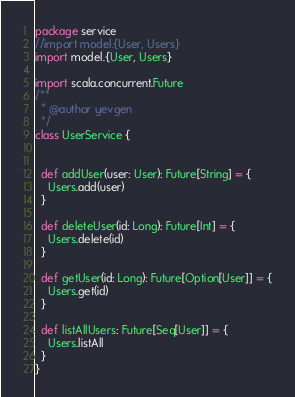Convert code to text. <code><loc_0><loc_0><loc_500><loc_500><_Scala_>package service
//import model.{User, Users}
import model.{User, Users}

import scala.concurrent.Future
/**
  * @author yevgen
  */
class UserService {


  def addUser(user: User): Future[String] = {
    Users.add(user)
  }

  def deleteUser(id: Long): Future[Int] = {
    Users.delete(id)
  }

  def getUser(id: Long): Future[Option[User]] = {
    Users.get(id)
  }

  def listAllUsers: Future[Seq[User]] = {
    Users.listAll
  }
}
</code> 